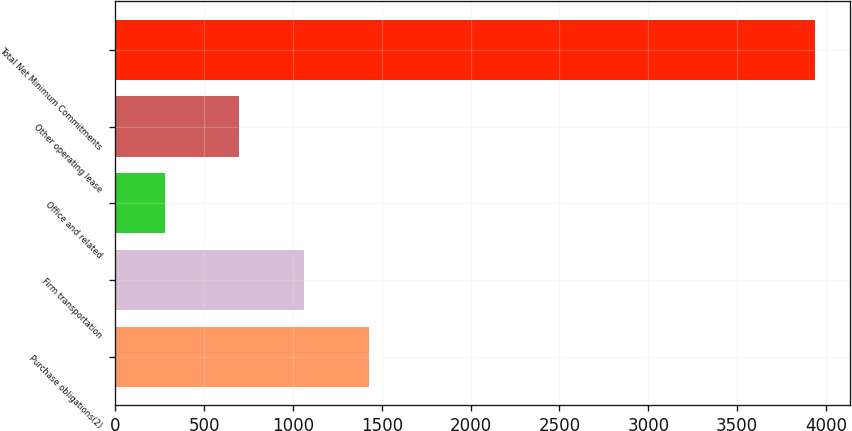Convert chart. <chart><loc_0><loc_0><loc_500><loc_500><bar_chart><fcel>Purchase obligations(2)<fcel>Firm transportation<fcel>Office and related<fcel>Other operating lease<fcel>Total Net Minimum Commitments<nl><fcel>1425.4<fcel>1059.7<fcel>281<fcel>694<fcel>3938<nl></chart> 